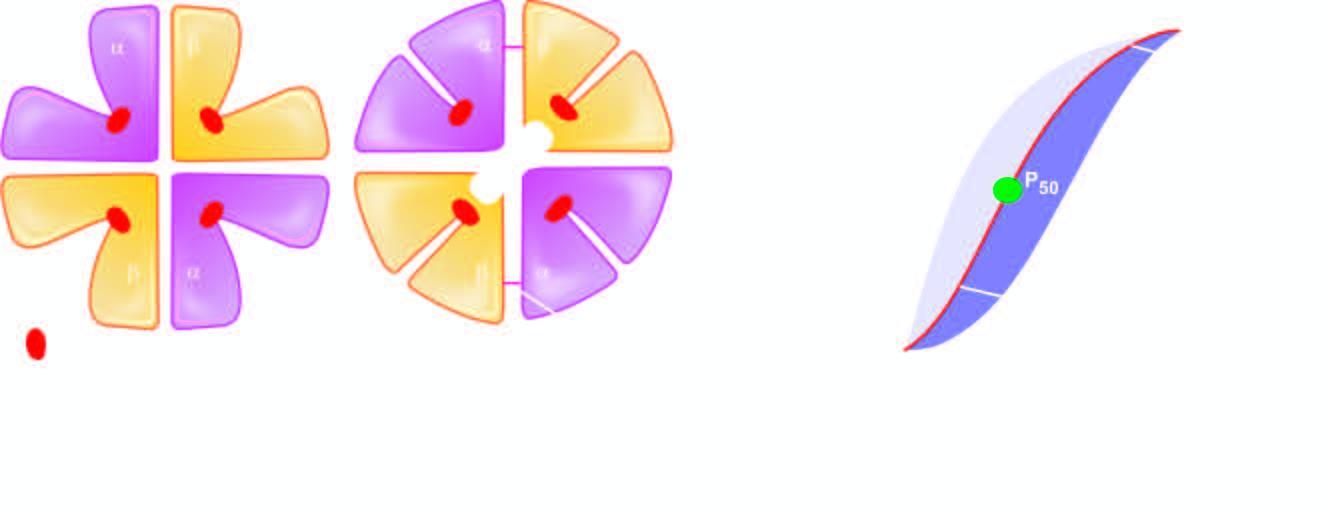re characteristics of cancer in a gland broken?
Answer the question using a single word or phrase. No 